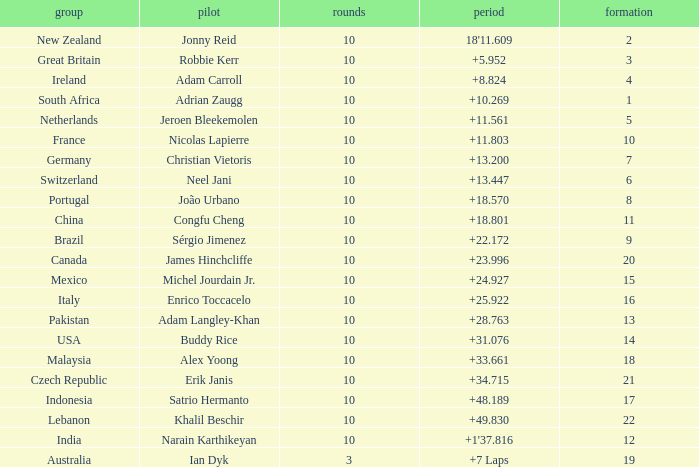What is the Grid number for the Team from Italy? 1.0. 